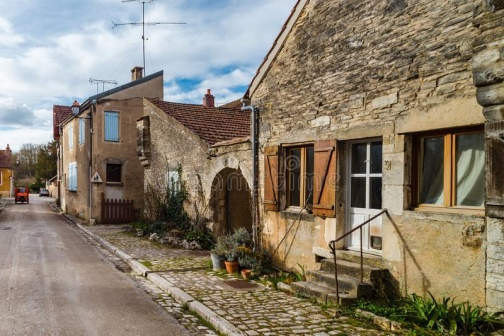How might the village look under different weather conditions? Under a blanket of snow, this village would transform into a winter wonderland. The cobblestone street would be covered in a pristine layer of snow, while the houses would wear a cap of white on their orange roofs. The garden plants might peek out from under the snow, adding a touch of green amidst the white. The street lamp would cast a warm, inviting glow, guiding anyone venturing into the frosty night.  How would it feel to walk through this village during a spring rain? Walking through this village during a spring rain would be a serene and refreshing experience. The cobblestones would glisten with the rain, and the sound of raindrops pattering on the roofs would create a soothing melody. The air would be filled with the earthy scent of rain and blooming flowers from the gardens. The wooden gates and shutters would absorb the moisture, giving the place an even cozier feel. It would be a sensory delight, highlighting the village's natural charm.  Imagine if this village was part of a fantastical realm. What magical elements might you find? In a fantastical realm, this village might be home to enchanting elements such as glowing lanterns that float above the cobblestone street, lighting the path with a soft, magical glow. The gardens could be filled with flowers that change colors with the time of day, creating a vibrant, ever-changing tapestry. Birds with iridescent feathers might sing melodious tunes that enchant anyone who listens, and the houses could be enchanted to subtly change their hues to reflect the inhabitants' moods. Perhaps the street lamp is actually a sentinel, coming to life at night to protect the village from any hidden dangers. 